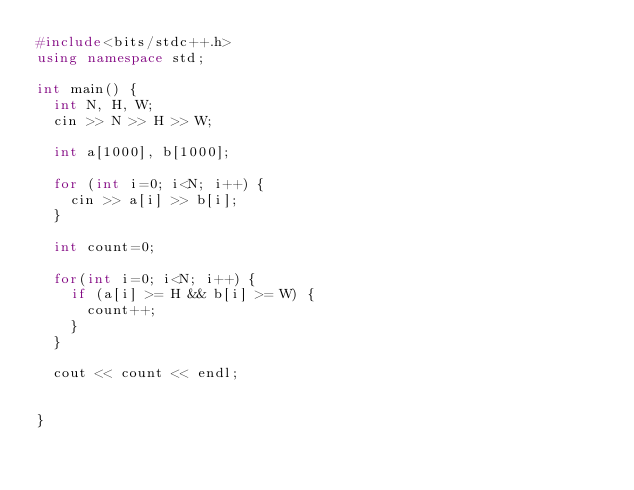Convert code to text. <code><loc_0><loc_0><loc_500><loc_500><_C++_>#include<bits/stdc++.h>
using namespace std;

int main() {
  int N, H, W;
  cin >> N >> H >> W;
  
  int a[1000], b[1000];
  
  for (int i=0; i<N; i++) {
    cin >> a[i] >> b[i];
  }
  
  int count=0;
  
  for(int i=0; i<N; i++) {
    if (a[i] >= H && b[i] >= W) {
      count++;
    }
  }
  
  cout << count << endl;
  
  
}</code> 